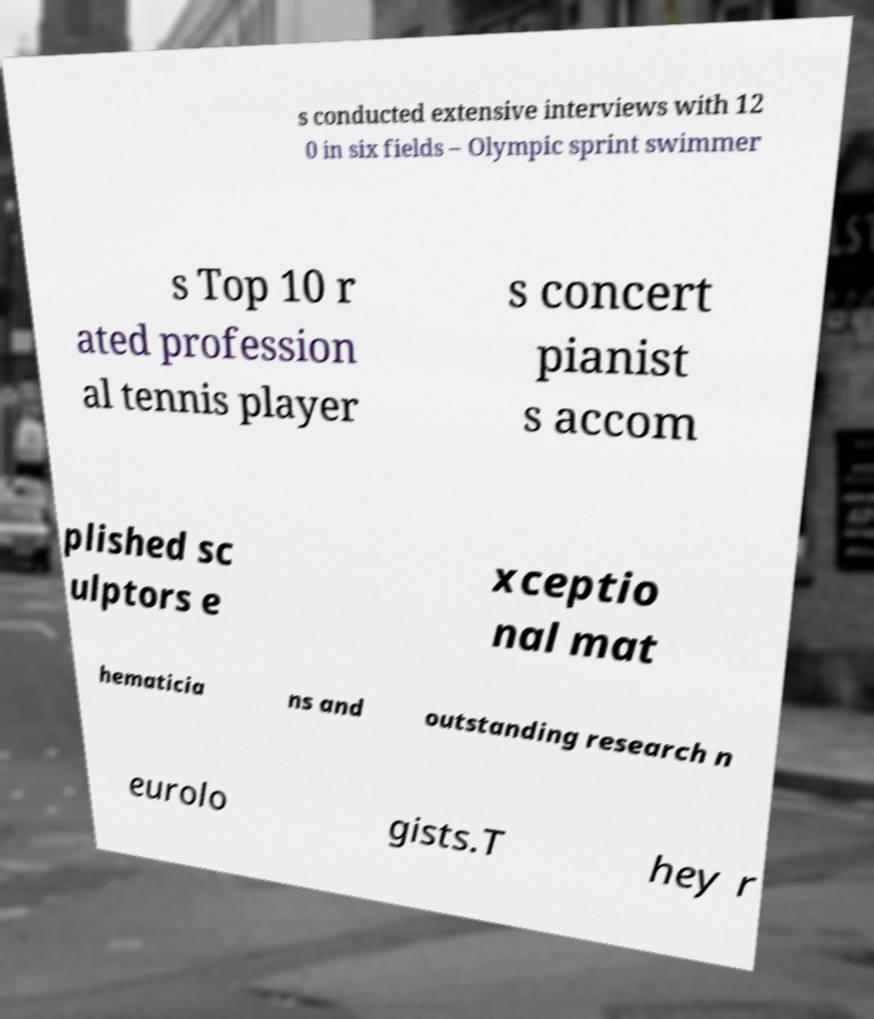For documentation purposes, I need the text within this image transcribed. Could you provide that? s conducted extensive interviews with 12 0 in six fields – Olympic sprint swimmer s Top 10 r ated profession al tennis player s concert pianist s accom plished sc ulptors e xceptio nal mat hematicia ns and outstanding research n eurolo gists.T hey r 